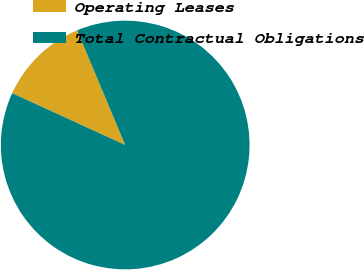<chart> <loc_0><loc_0><loc_500><loc_500><pie_chart><fcel>Operating Leases<fcel>Total Contractual Obligations<nl><fcel>11.84%<fcel>88.16%<nl></chart> 